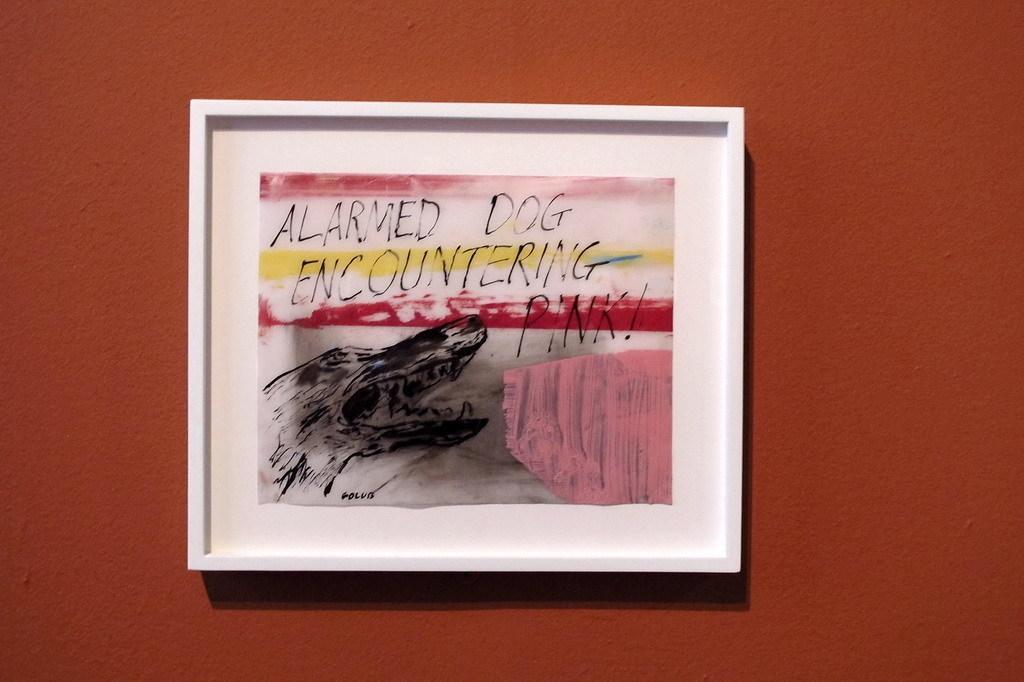In one or two sentences, can you explain what this image depicts? This picture shows a painting on the wall. We see text on it. The wall is brown in color. 